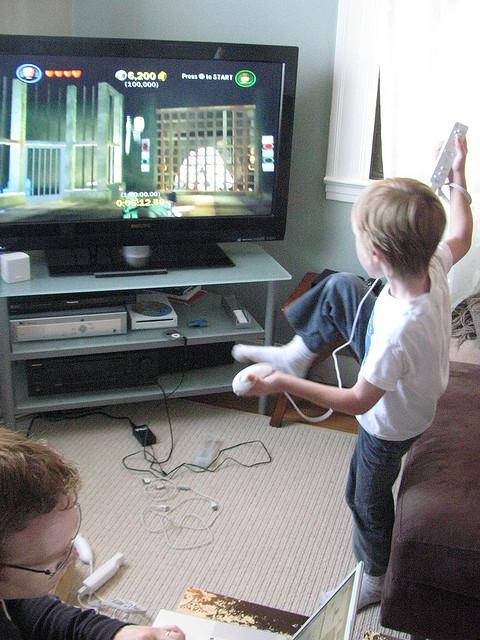How many children are wearing glasses?
Write a very short answer. 1. What type of game system is the boy playing?
Answer briefly. Wii. Is the room neat?
Quick response, please. No. 